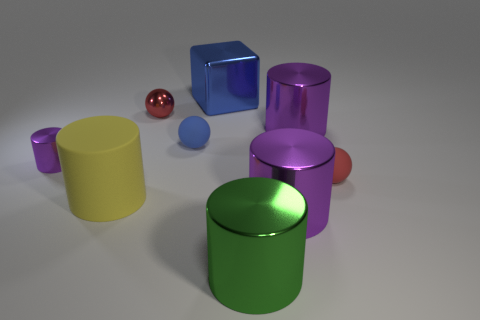What is the shape of the matte object that is the same color as the big metallic block?
Give a very brief answer. Sphere. Do the purple metal thing that is on the left side of the yellow object and the purple metal thing in front of the big matte object have the same size?
Provide a short and direct response. No. There is a tiny object that is both behind the small purple metallic cylinder and to the right of the tiny red metallic sphere; what shape is it?
Your answer should be very brief. Sphere. Are there any red balls that have the same material as the yellow object?
Offer a very short reply. Yes. There is a thing that is the same color as the big shiny cube; what material is it?
Your answer should be very brief. Rubber. Are the purple cylinder that is to the left of the small red metal thing and the large purple thing that is behind the yellow matte object made of the same material?
Provide a short and direct response. Yes. Are there more metal things than blue blocks?
Keep it short and to the point. Yes. The rubber sphere to the right of the blue rubber ball right of the metallic cylinder on the left side of the yellow matte cylinder is what color?
Your answer should be very brief. Red. Do the rubber object that is to the right of the big blue metallic thing and the small metal thing on the right side of the big rubber cylinder have the same color?
Offer a very short reply. Yes. How many yellow matte cylinders are on the left side of the purple shiny object on the left side of the big yellow matte thing?
Your response must be concise. 0. 